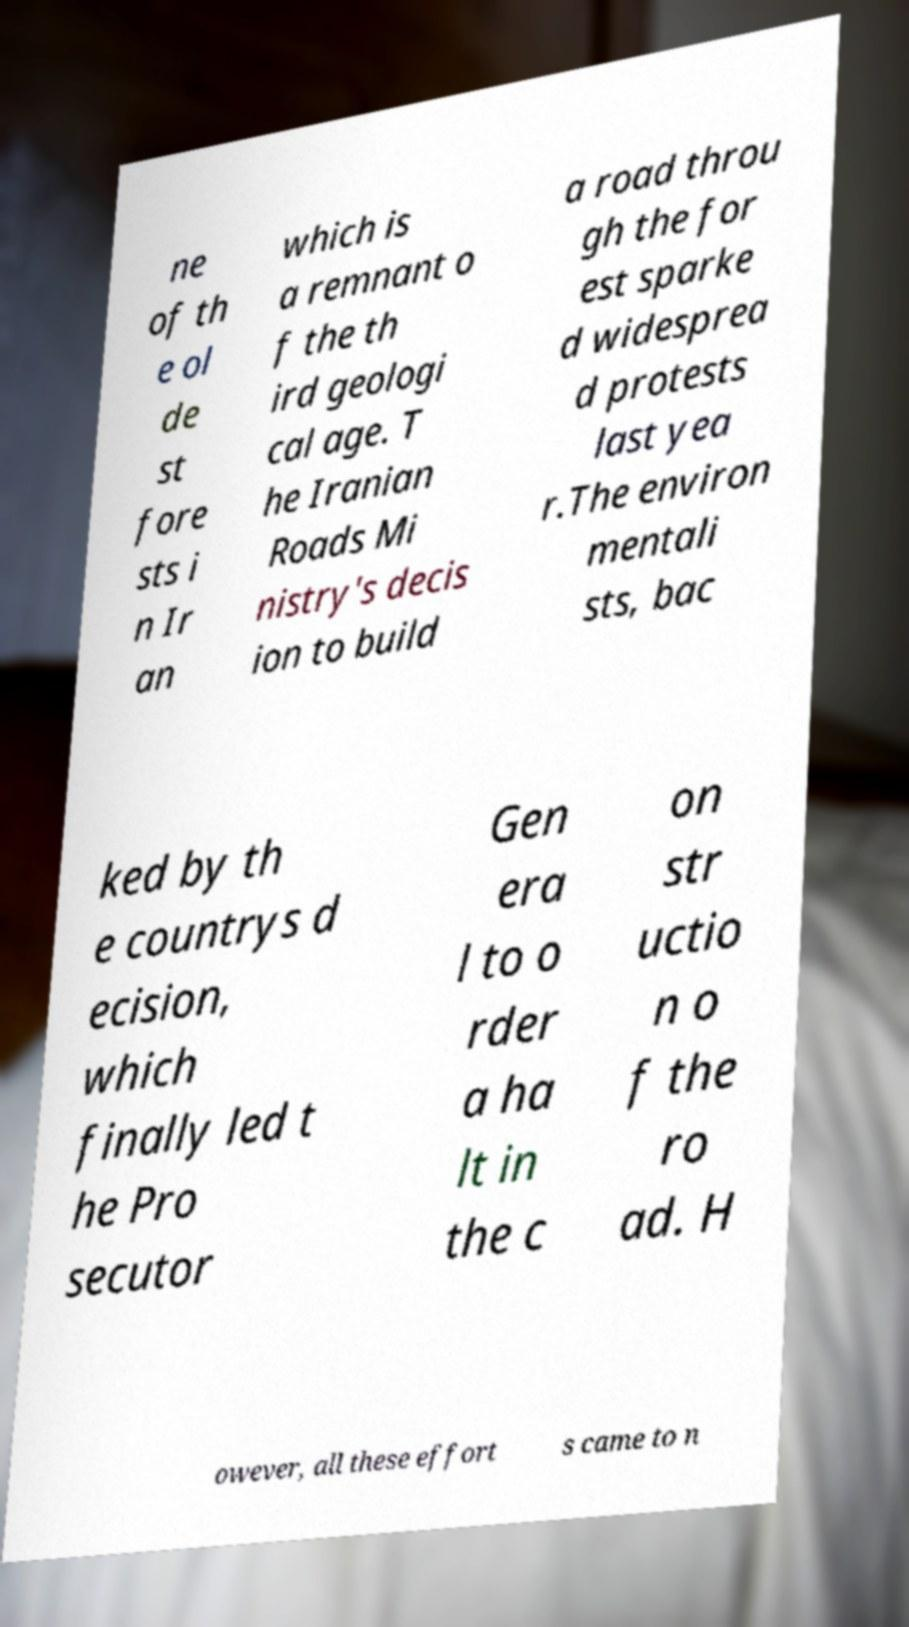Please read and relay the text visible in this image. What does it say? ne of th e ol de st fore sts i n Ir an which is a remnant o f the th ird geologi cal age. T he Iranian Roads Mi nistry's decis ion to build a road throu gh the for est sparke d widesprea d protests last yea r.The environ mentali sts, bac ked by th e countrys d ecision, which finally led t he Pro secutor Gen era l to o rder a ha lt in the c on str uctio n o f the ro ad. H owever, all these effort s came to n 